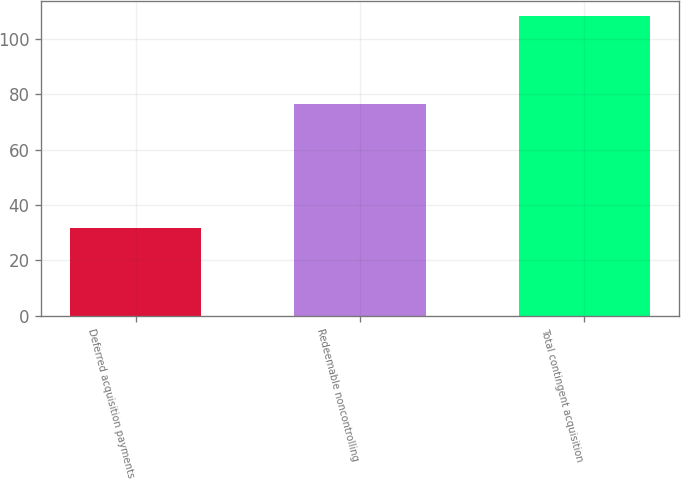Convert chart. <chart><loc_0><loc_0><loc_500><loc_500><bar_chart><fcel>Deferred acquisition payments<fcel>Redeemable noncontrolling<fcel>Total contingent acquisition<nl><fcel>31.6<fcel>76.5<fcel>108.1<nl></chart> 